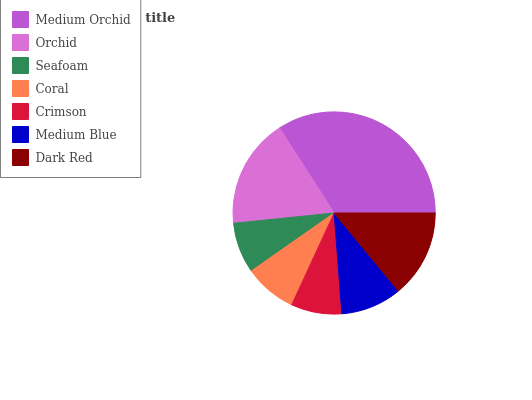Is Seafoam the minimum?
Answer yes or no. Yes. Is Medium Orchid the maximum?
Answer yes or no. Yes. Is Orchid the minimum?
Answer yes or no. No. Is Orchid the maximum?
Answer yes or no. No. Is Medium Orchid greater than Orchid?
Answer yes or no. Yes. Is Orchid less than Medium Orchid?
Answer yes or no. Yes. Is Orchid greater than Medium Orchid?
Answer yes or no. No. Is Medium Orchid less than Orchid?
Answer yes or no. No. Is Medium Blue the high median?
Answer yes or no. Yes. Is Medium Blue the low median?
Answer yes or no. Yes. Is Orchid the high median?
Answer yes or no. No. Is Seafoam the low median?
Answer yes or no. No. 